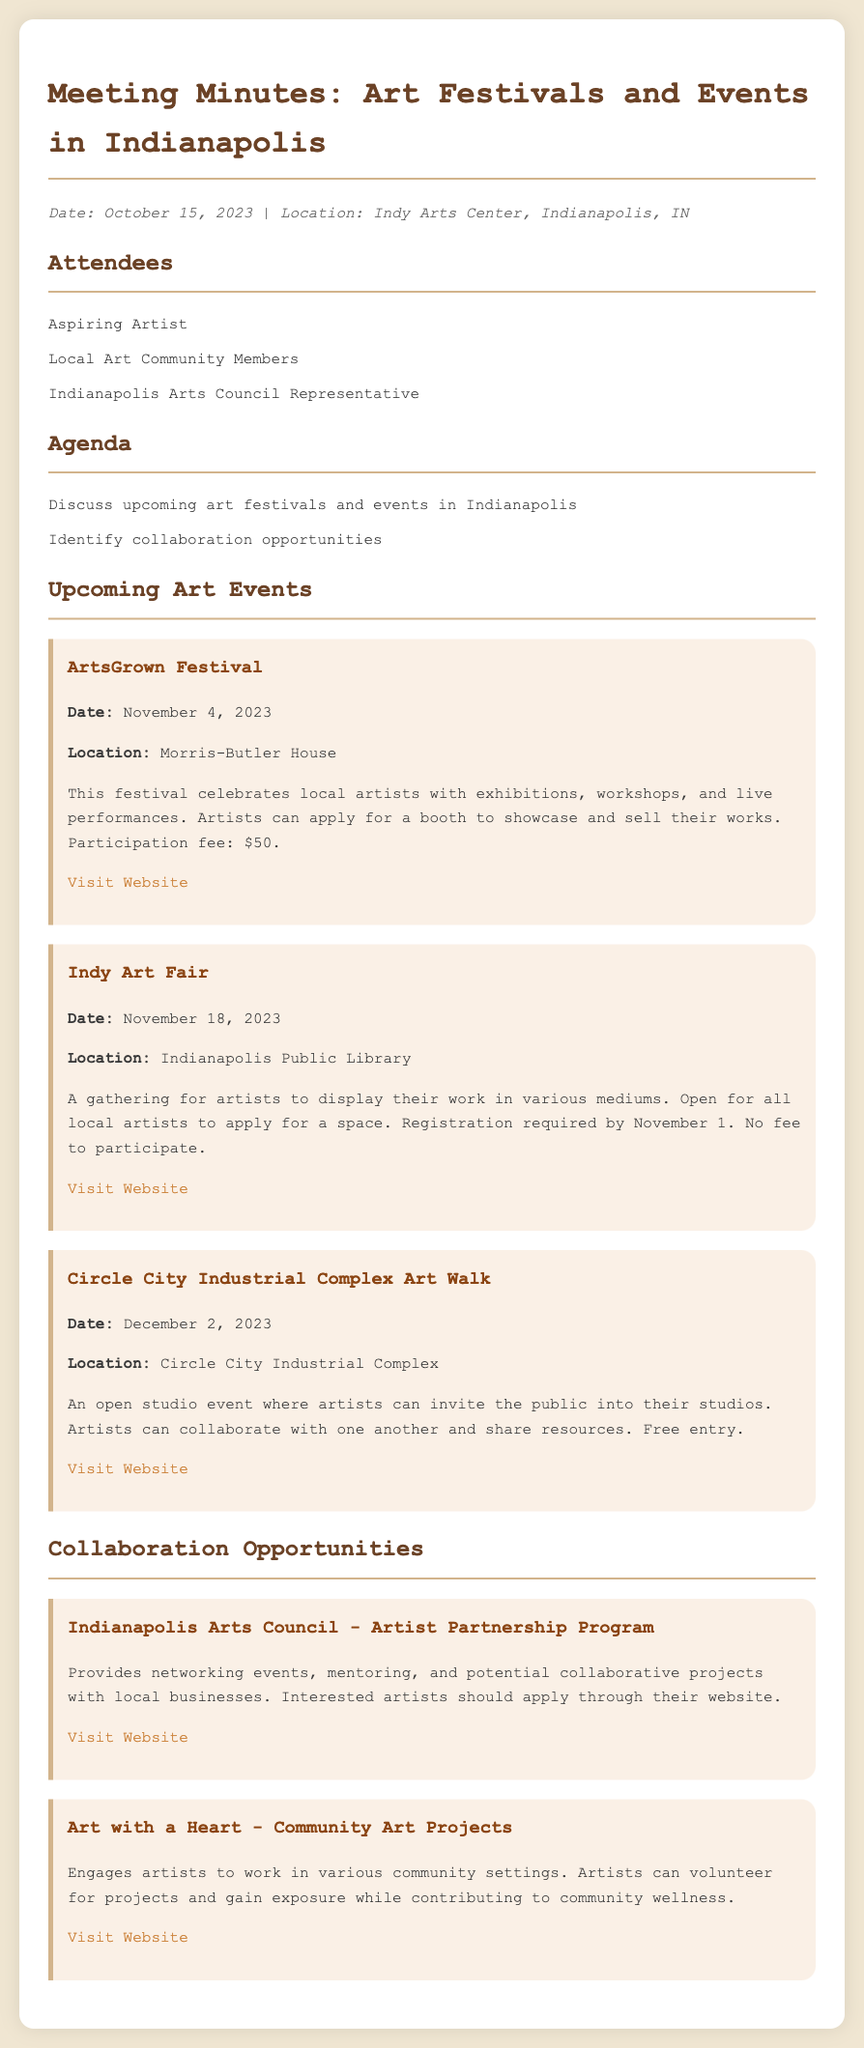What is the date of the ArtsGrown Festival? The ArtsGrown Festival is scheduled for November 4, 2023.
Answer: November 4, 2023 Where will the Indy Art Fair be held? The Indy Art Fair will take place at the Indianapolis Public Library.
Answer: Indianapolis Public Library What is the participation fee for the ArtsGrown Festival? The participation fee for the ArtsGrown Festival is mentioned as $50 in the document.
Answer: $50 When is the registration deadline for the Indy Art Fair? The registration for the Indy Art Fair is required by November 1, 2023.
Answer: November 1 What type of event is the Circle City Industrial Complex Art Walk? The Circle City Industrial Complex Art Walk is described as an open studio event.
Answer: open studio event Which organization offers the Artist Partnership Program? The Artist Partnership Program is provided by the Indianapolis Arts Council.
Answer: Indianapolis Arts Council What type of projects does Art with a Heart focus on? Art with a Heart engages artists in community art projects.
Answer: community art projects What is the main benefit of the Indianapolis Arts Council's program? The program provides networking events for artists.
Answer: networking events How many upcoming art events are listed in the document? There are three upcoming art events listed in the document.
Answer: Three 